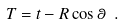Convert formula to latex. <formula><loc_0><loc_0><loc_500><loc_500>T = t - R \cos \theta \ .</formula> 